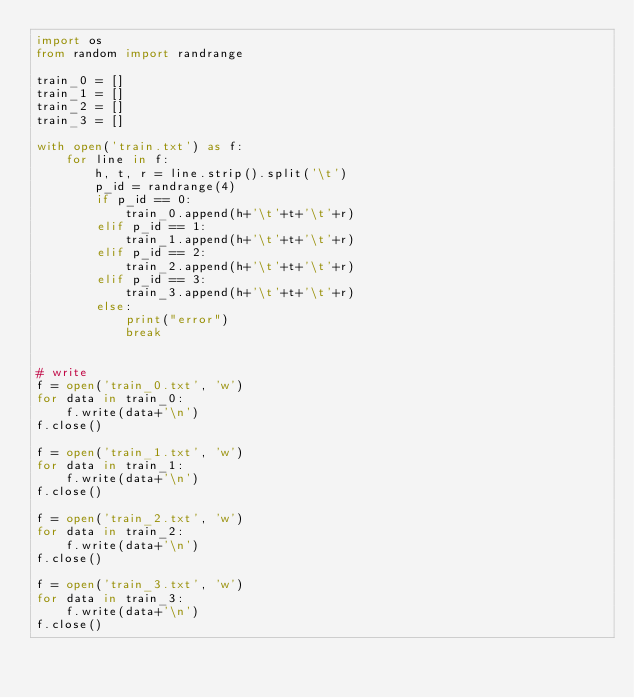Convert code to text. <code><loc_0><loc_0><loc_500><loc_500><_Python_>import os
from random import randrange

train_0 = []
train_1 = []
train_2 = []
train_3 = []

with open('train.txt') as f:
    for line in f:
        h, t, r = line.strip().split('\t')
        p_id = randrange(4)
        if p_id == 0:
            train_0.append(h+'\t'+t+'\t'+r)
        elif p_id == 1:
            train_1.append(h+'\t'+t+'\t'+r)
        elif p_id == 2:
            train_2.append(h+'\t'+t+'\t'+r)
        elif p_id == 3:
            train_3.append(h+'\t'+t+'\t'+r)
        else:
            print("error")
            break


# write
f = open('train_0.txt', 'w')
for data in train_0:
    f.write(data+'\n')
f.close()

f = open('train_1.txt', 'w')
for data in train_1:
    f.write(data+'\n')
f.close()

f = open('train_2.txt', 'w')
for data in train_2:
    f.write(data+'\n')
f.close()

f = open('train_3.txt', 'w')
for data in train_3:
    f.write(data+'\n')
f.close()
</code> 